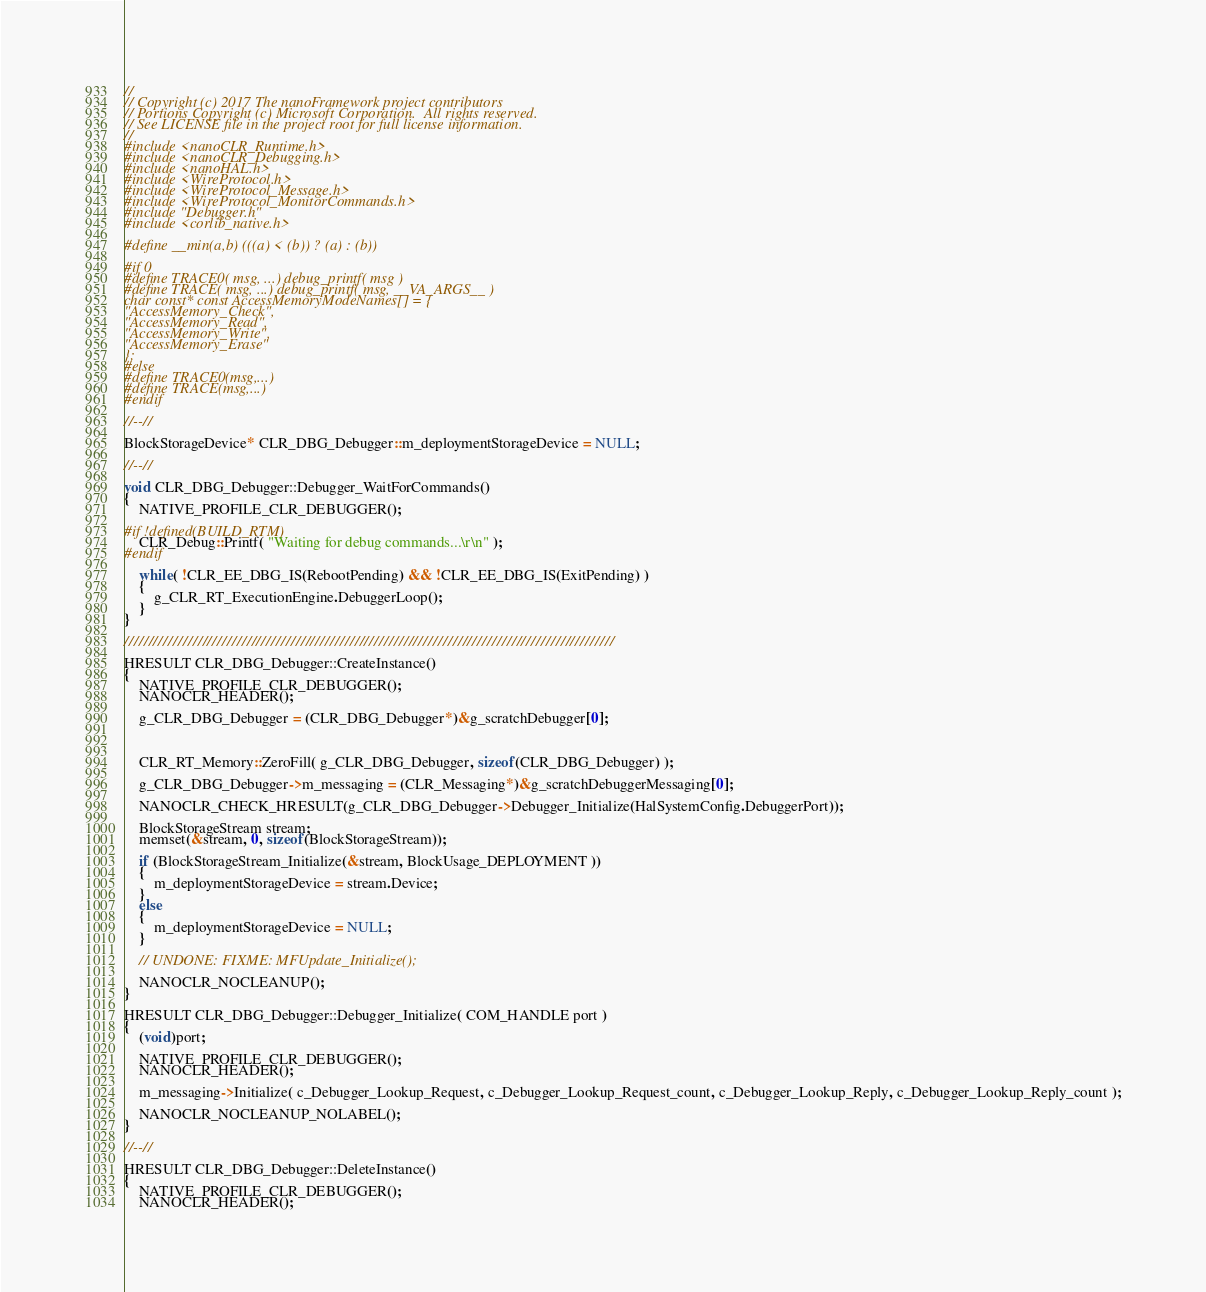Convert code to text. <code><loc_0><loc_0><loc_500><loc_500><_C++_>//
// Copyright (c) 2017 The nanoFramework project contributors
// Portions Copyright (c) Microsoft Corporation.  All rights reserved.
// See LICENSE file in the project root for full license information.
//
#include <nanoCLR_Runtime.h>
#include <nanoCLR_Debugging.h>
#include <nanoHAL.h>
#include <WireProtocol.h>
#include <WireProtocol_Message.h>
#include <WireProtocol_MonitorCommands.h>
#include "Debugger.h"
#include <corlib_native.h>

#define __min(a,b) (((a) < (b)) ? (a) : (b))

#if 0
#define TRACE0( msg, ...) debug_printf( msg ) 
#define TRACE( msg, ...) debug_printf( msg, __VA_ARGS__ ) 
char const* const AccessMemoryModeNames[] = {
"AccessMemory_Check",
"AccessMemory_Read", 
"AccessMemory_Write",
"AccessMemory_Erase"
};
#else
#define TRACE0(msg,...)
#define TRACE(msg,...)
#endif

//--//

BlockStorageDevice* CLR_DBG_Debugger::m_deploymentStorageDevice = NULL;

//--//

void CLR_DBG_Debugger::Debugger_WaitForCommands()
{
    NATIVE_PROFILE_CLR_DEBUGGER();

#if !defined(BUILD_RTM)
    CLR_Debug::Printf( "Waiting for debug commands...\r\n" );
#endif

    while( !CLR_EE_DBG_IS(RebootPending) && !CLR_EE_DBG_IS(ExitPending) )
    {
        g_CLR_RT_ExecutionEngine.DebuggerLoop();
    }
}

////////////////////////////////////////////////////////////////////////////////////////////////////

HRESULT CLR_DBG_Debugger::CreateInstance()
{
    NATIVE_PROFILE_CLR_DEBUGGER();
    NANOCLR_HEADER();

    g_CLR_DBG_Debugger = (CLR_DBG_Debugger*)&g_scratchDebugger[0];



    CLR_RT_Memory::ZeroFill( g_CLR_DBG_Debugger, sizeof(CLR_DBG_Debugger) );

    g_CLR_DBG_Debugger->m_messaging = (CLR_Messaging*)&g_scratchDebuggerMessaging[0];

    NANOCLR_CHECK_HRESULT(g_CLR_DBG_Debugger->Debugger_Initialize(HalSystemConfig.DebuggerPort));

    BlockStorageStream stream;
    memset(&stream, 0, sizeof(BlockStorageStream));

    if (BlockStorageStream_Initialize(&stream, BlockUsage_DEPLOYMENT ))
    {
        m_deploymentStorageDevice = stream.Device;
    }
    else
    {
        m_deploymentStorageDevice = NULL;
    }

    // UNDONE: FIXME: MFUpdate_Initialize();

    NANOCLR_NOCLEANUP();
}

HRESULT CLR_DBG_Debugger::Debugger_Initialize( COM_HANDLE port )
{
    (void)port;

    NATIVE_PROFILE_CLR_DEBUGGER();
    NANOCLR_HEADER();

    m_messaging->Initialize( c_Debugger_Lookup_Request, c_Debugger_Lookup_Request_count, c_Debugger_Lookup_Reply, c_Debugger_Lookup_Reply_count );

    NANOCLR_NOCLEANUP_NOLABEL();
}

//--//

HRESULT CLR_DBG_Debugger::DeleteInstance()
{
    NATIVE_PROFILE_CLR_DEBUGGER();
    NANOCLR_HEADER();
</code> 